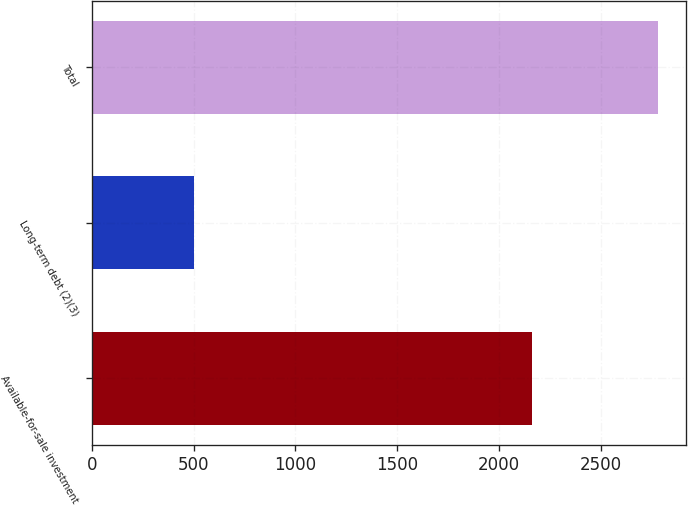Convert chart to OTSL. <chart><loc_0><loc_0><loc_500><loc_500><bar_chart><fcel>Available-for-sale investment<fcel>Long-term debt (2)(3)<fcel>Total<nl><fcel>2165<fcel>500<fcel>2783<nl></chart> 